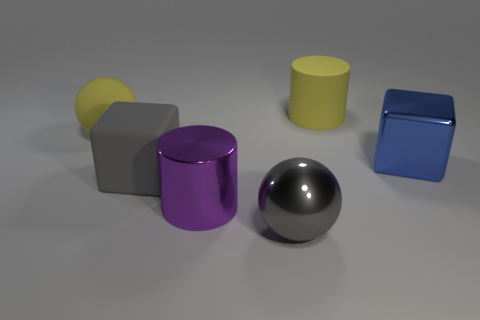What is the shape of the object that is the same color as the matte cube?
Your answer should be compact. Sphere. Is the blue thing the same shape as the big gray metal thing?
Ensure brevity in your answer.  No. The large object that is to the right of the large gray rubber block and behind the metallic cube is made of what material?
Your answer should be very brief. Rubber. What is the size of the purple metallic cylinder?
Make the answer very short. Large. What color is the large shiny thing that is the same shape as the gray rubber object?
Provide a short and direct response. Blue. Are there any other things that have the same color as the matte block?
Make the answer very short. Yes. Does the yellow thing that is in front of the large matte cylinder have the same size as the shiny thing behind the big gray matte cube?
Your response must be concise. Yes. Are there the same number of cubes that are on the left side of the large gray rubber cube and yellow cylinders in front of the gray ball?
Your answer should be compact. Yes. There is a gray rubber object; does it have the same size as the cylinder behind the shiny block?
Provide a short and direct response. Yes. Is there a large rubber thing that is in front of the large shiny thing to the right of the large yellow rubber cylinder?
Your answer should be very brief. Yes. 